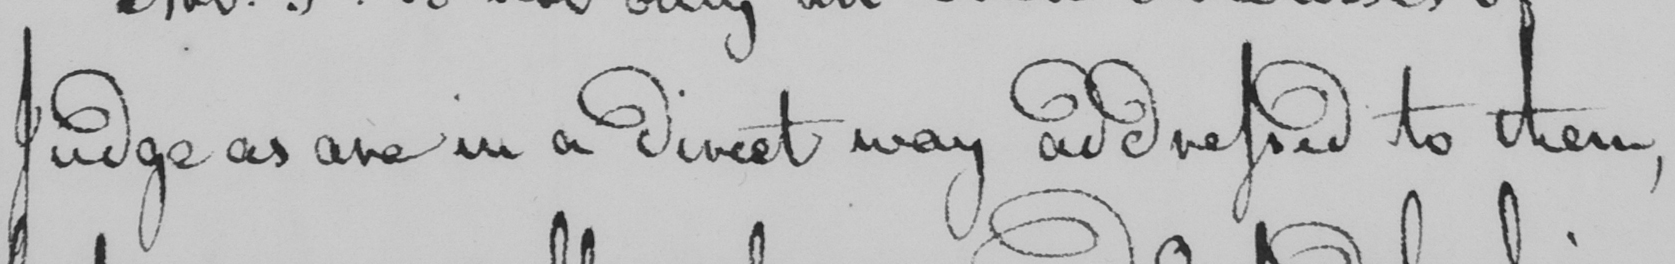Can you read and transcribe this handwriting? Judge as are in a direct way addressed to them , 